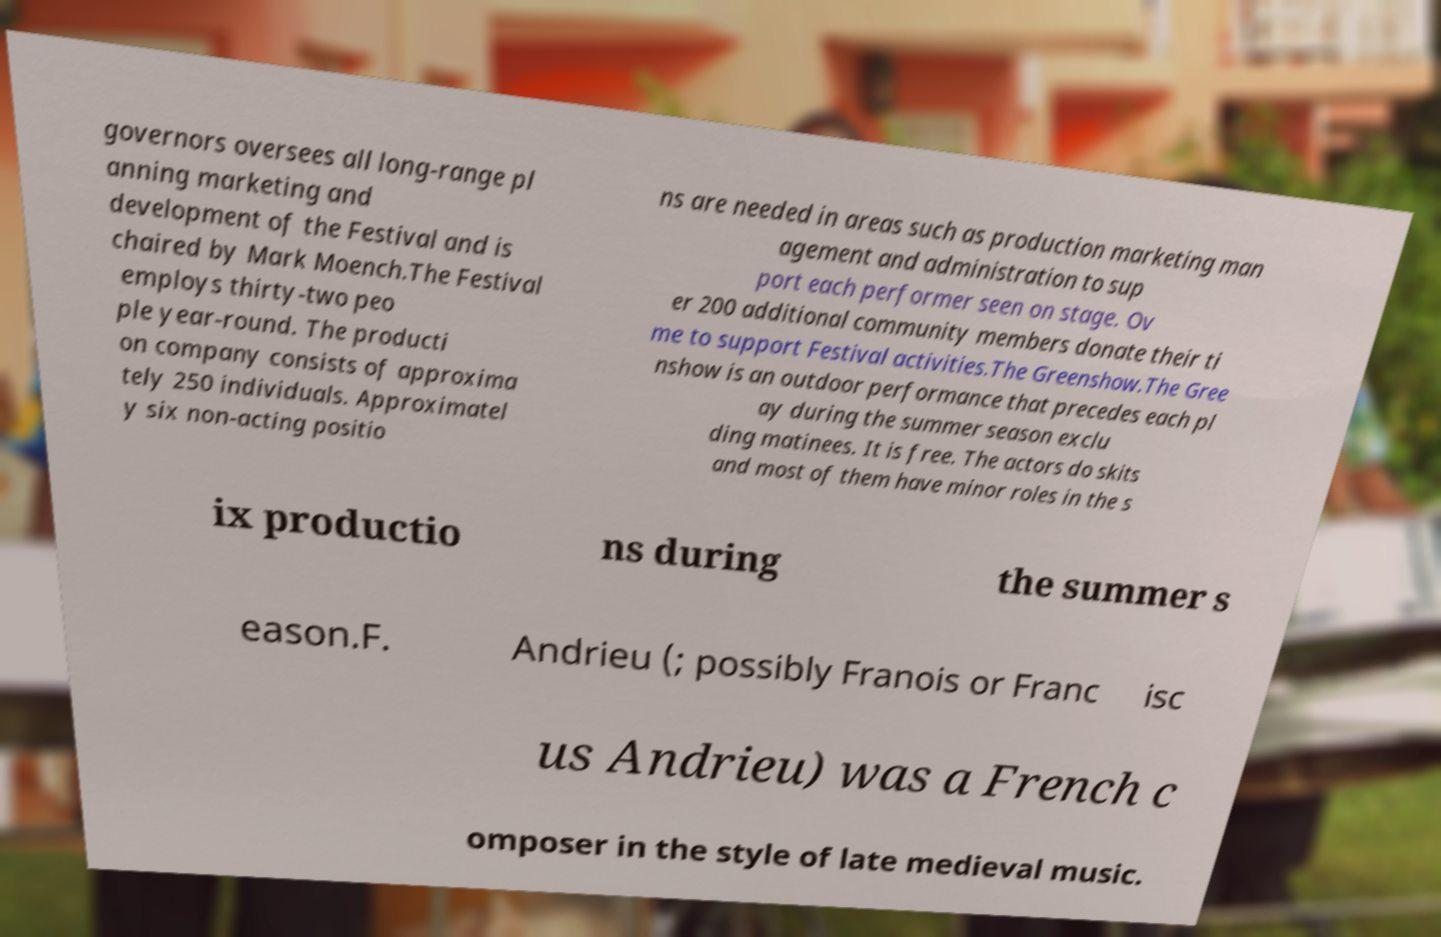Could you extract and type out the text from this image? governors oversees all long-range pl anning marketing and development of the Festival and is chaired by Mark Moench.The Festival employs thirty-two peo ple year-round. The producti on company consists of approxima tely 250 individuals. Approximatel y six non-acting positio ns are needed in areas such as production marketing man agement and administration to sup port each performer seen on stage. Ov er 200 additional community members donate their ti me to support Festival activities.The Greenshow.The Gree nshow is an outdoor performance that precedes each pl ay during the summer season exclu ding matinees. It is free. The actors do skits and most of them have minor roles in the s ix productio ns during the summer s eason.F. Andrieu (; possibly Franois or Franc isc us Andrieu) was a French c omposer in the style of late medieval music. 